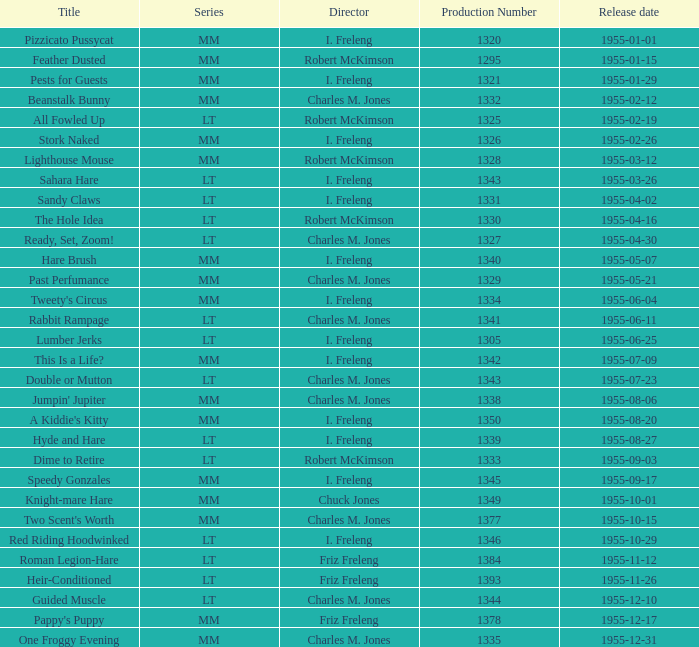What is the maximum production number released on 1955-04-02 with i. freleng as the director? 1331.0. 